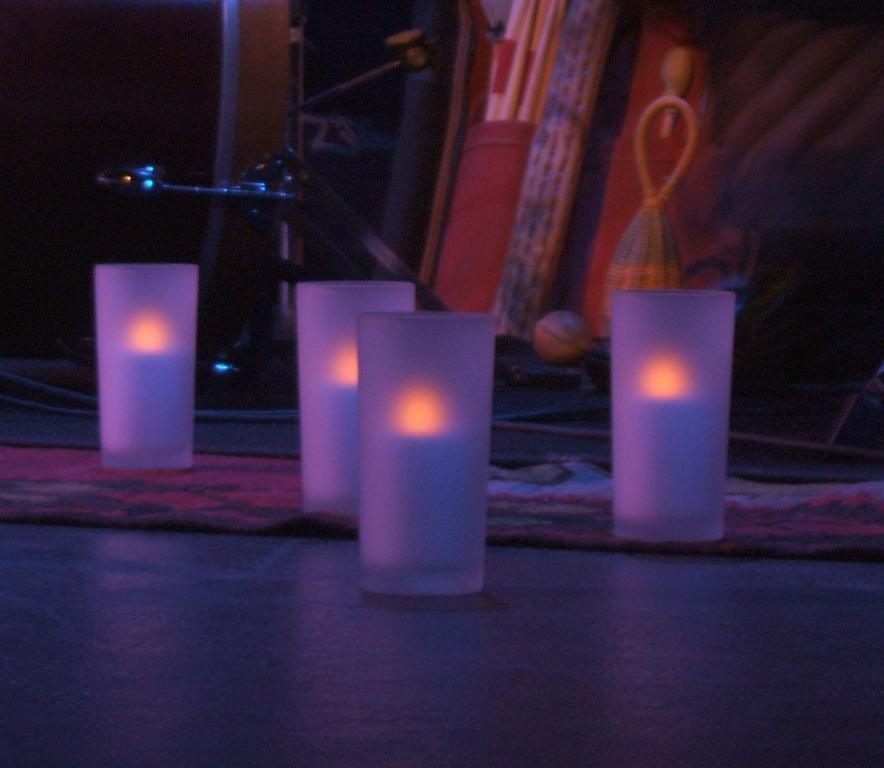What is located on the ground in the center of the image? There are glasses on the ground in the center of the image. What can be seen in the background of the image? There are objects in the background of the image. Can you describe a specific feature in the background? Yes, there is a pillar in the background of the image. What type of story is the monkey telling in the image? There is no monkey present in the image, so it is not possible to answer that question. 